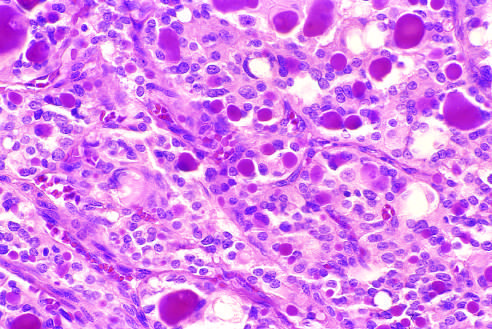does the lesion contain recognizable colloid?
Answer the question using a single word or phrase. No 